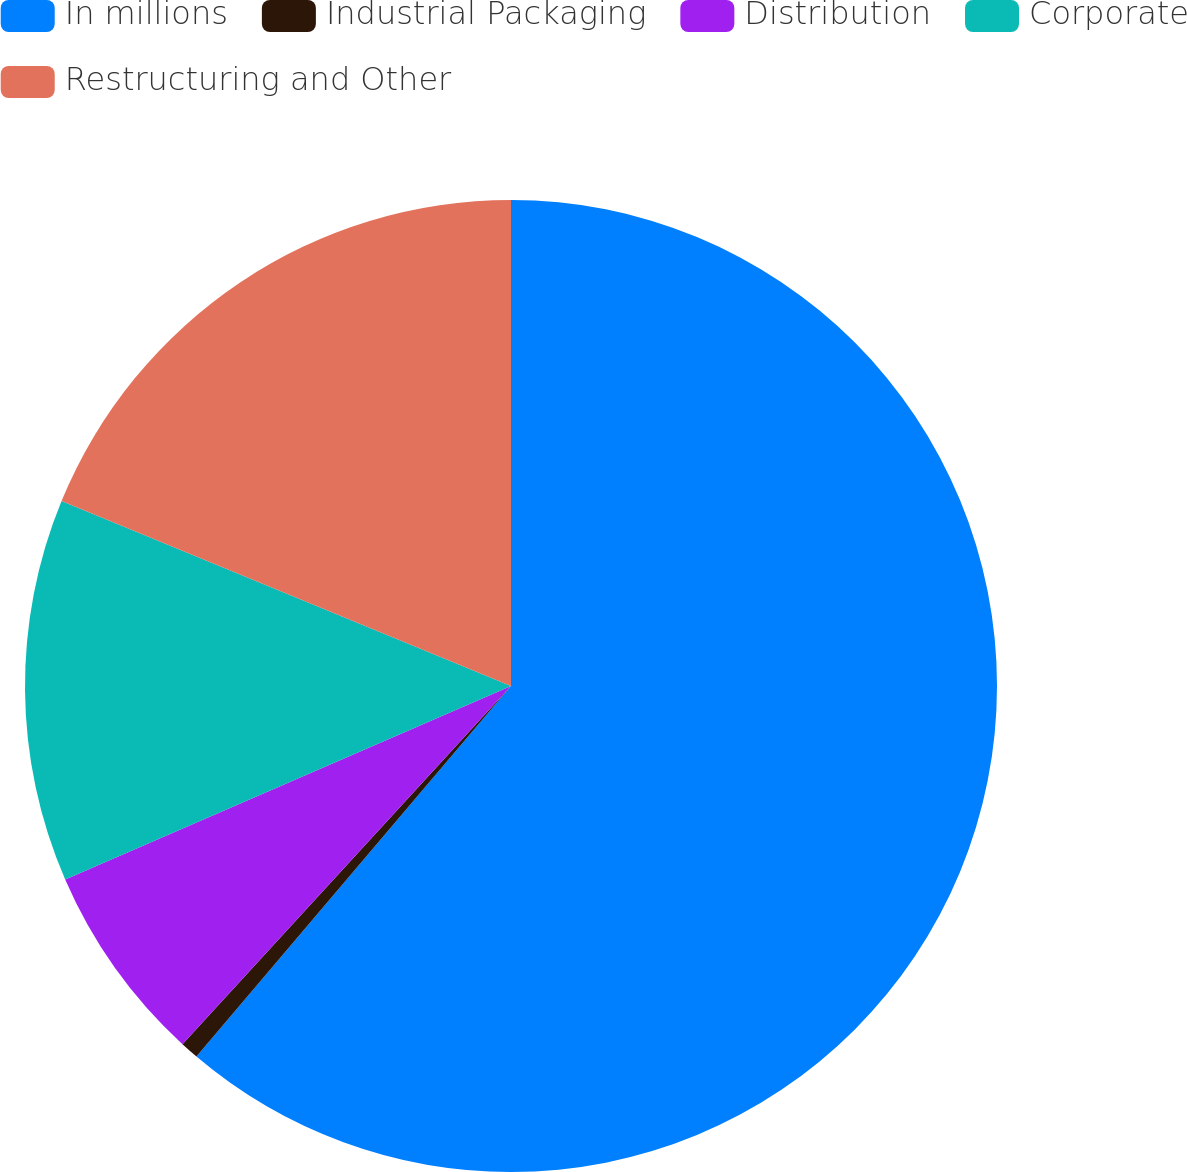Convert chart. <chart><loc_0><loc_0><loc_500><loc_500><pie_chart><fcel>In millions<fcel>Industrial Packaging<fcel>Distribution<fcel>Corporate<fcel>Restructuring and Other<nl><fcel>61.21%<fcel>0.61%<fcel>6.67%<fcel>12.73%<fcel>18.79%<nl></chart> 